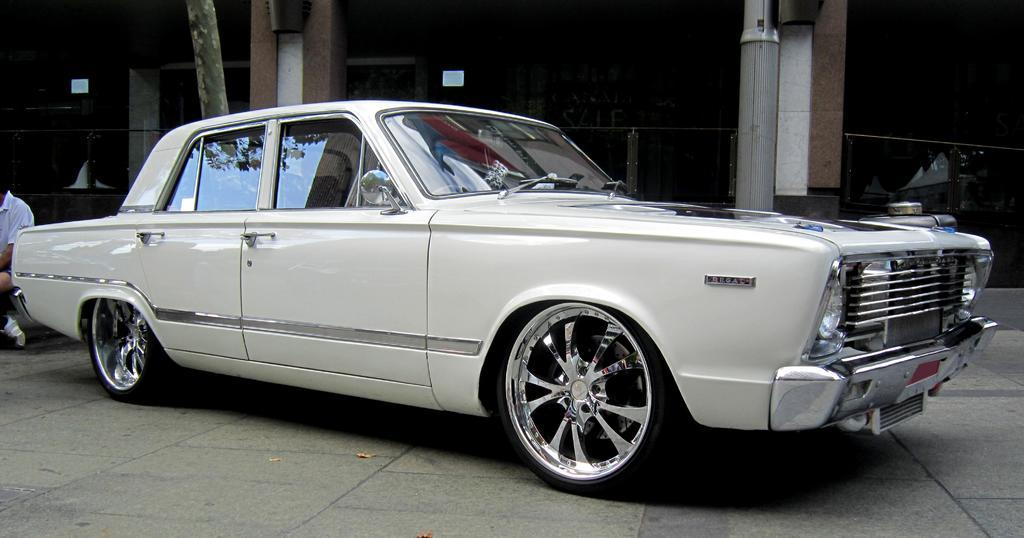What is the main subject in the foreground of the image? There is a car on the road in the foreground. Can you describe any people visible in the image? A man is visible on the left side of the image. What is the man wearing? The man is wearing a white T-shirt. What can be seen in the background of the image? There are pillars of a building in the background. How many zippers can be seen on the car in the image? There are no zippers present on the car in the image. What type of order is the man following in the image? There is no indication of the man following any specific order in the image. 